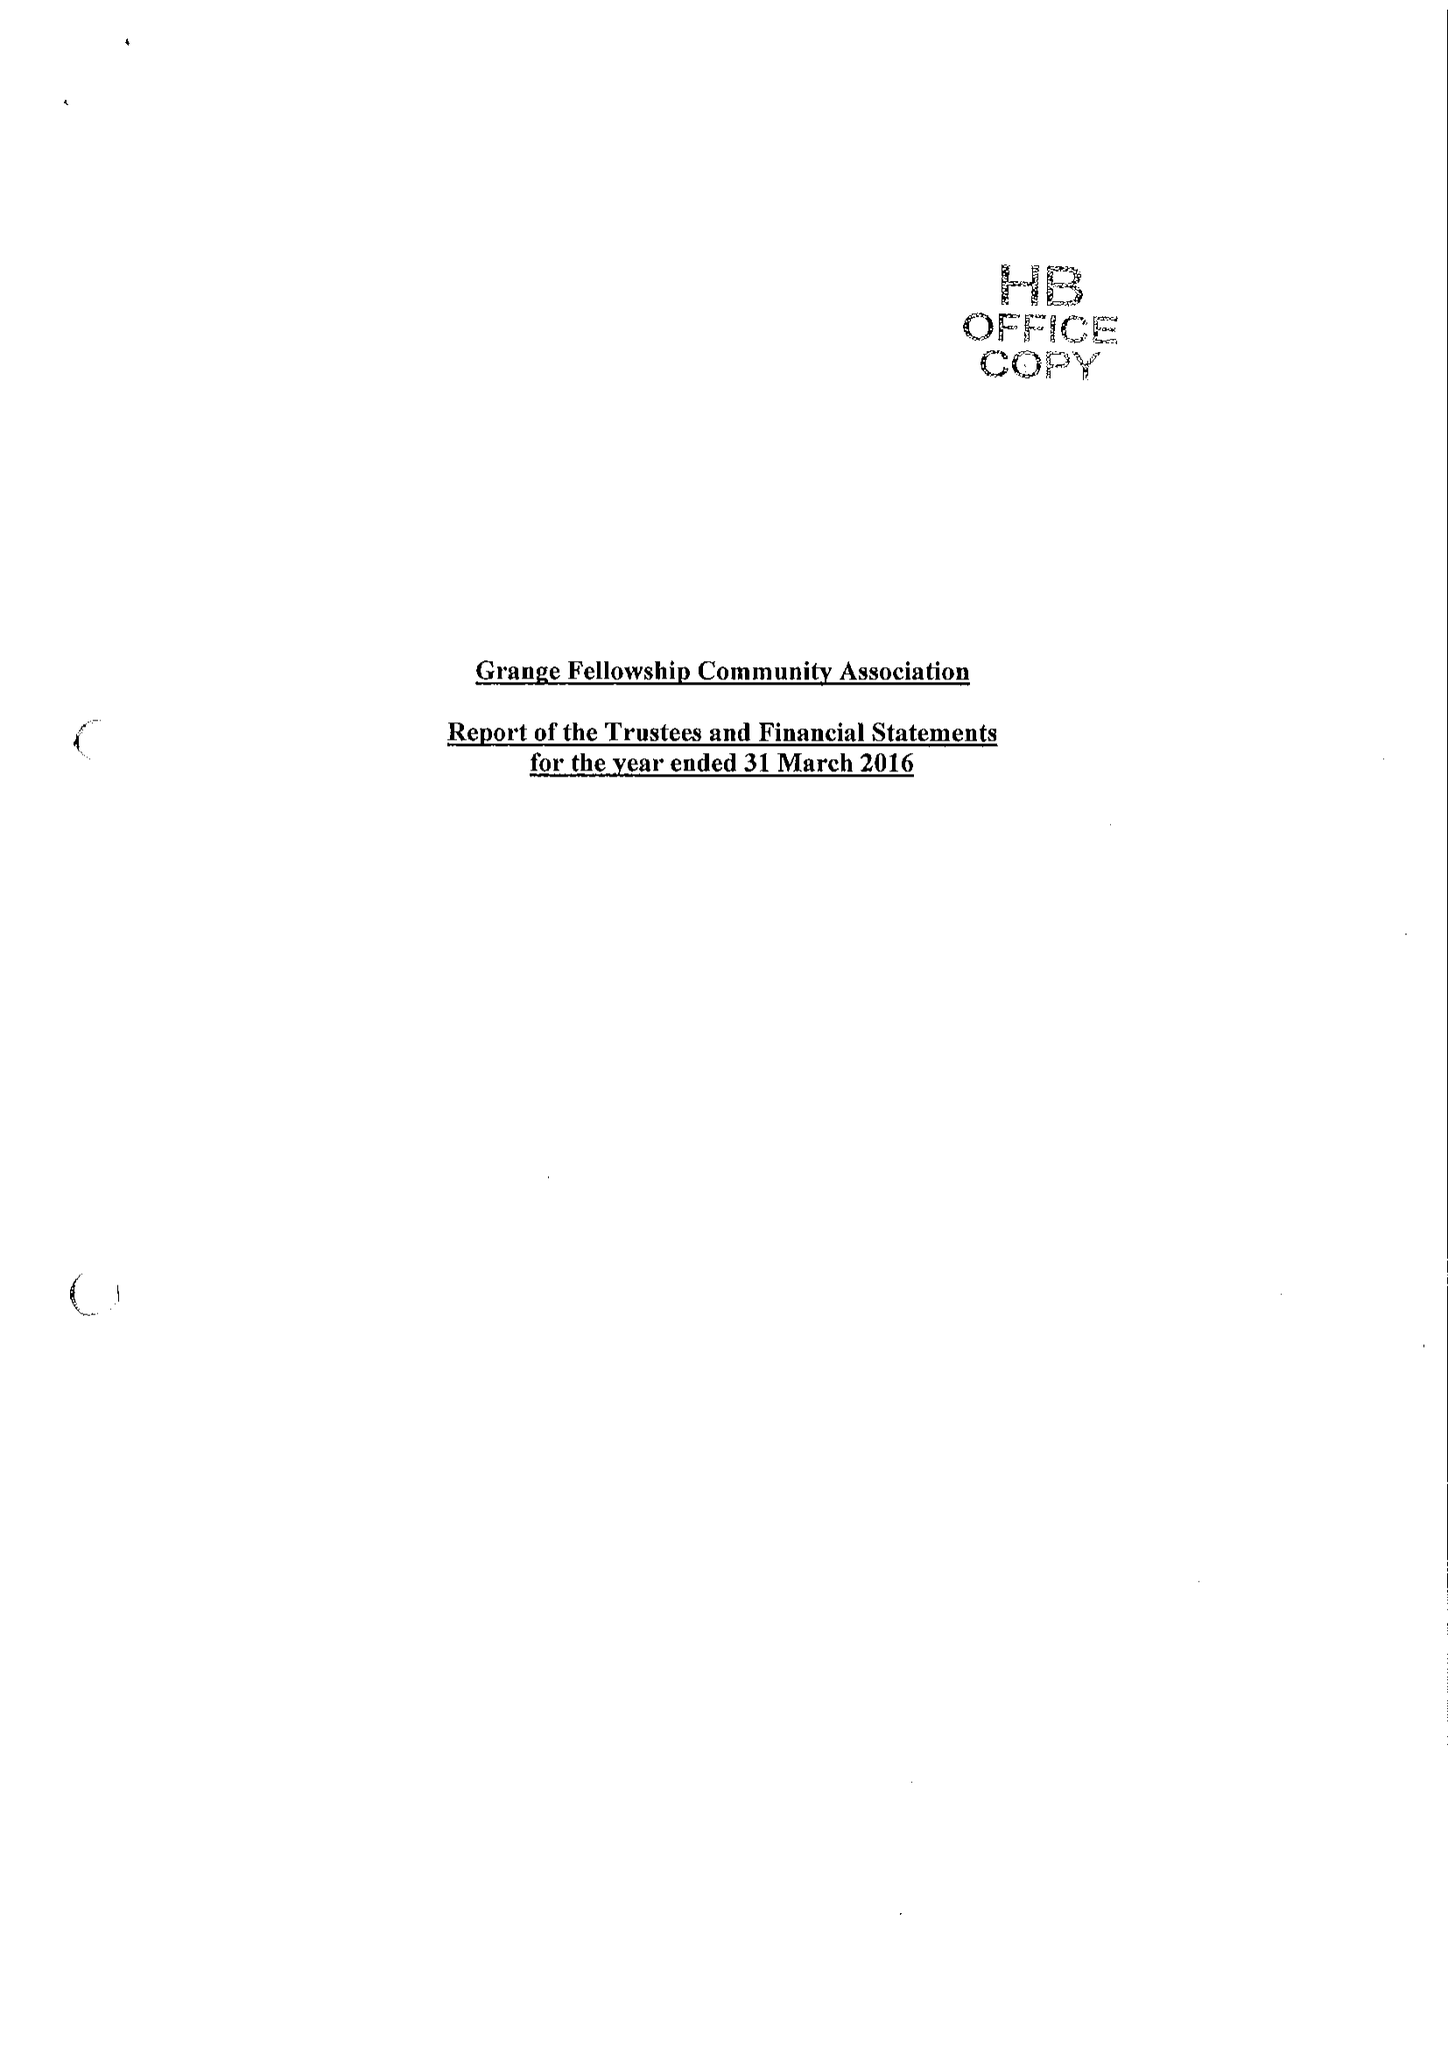What is the value for the spending_annually_in_british_pounds?
Answer the question using a single word or phrase. 470563.00 